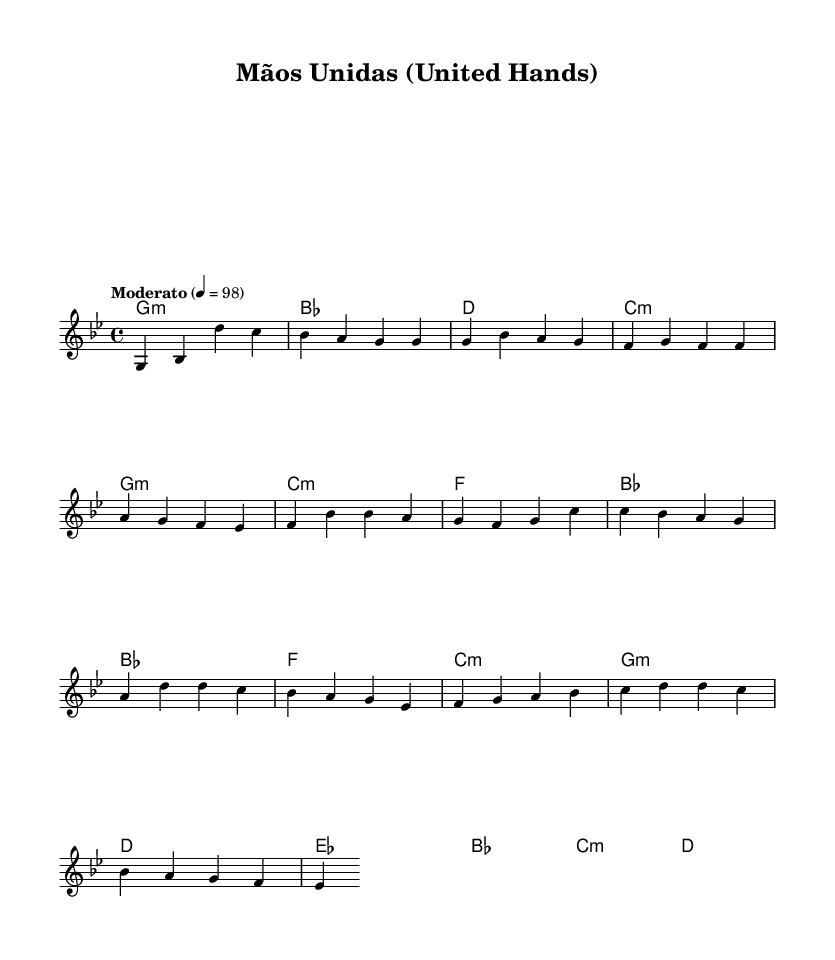What is the key signature of this music? The key signature is G minor, which has two flats. You can determine the key signature by looking at the beginning of the staff, which indicates the sharps or flats present. In this case, the G minor key signature is evident.
Answer: G minor What is the time signature of this piece? The time signature is 4/4, located at the beginning of the sheet music right after the clef and key signature. It shows that there are four beats in each measure and a quarter note receives one beat.
Answer: 4/4 What is the tempo marking for this piece? The tempo marking is "Moderato," which indicates a moderate pace for the song's performance. It is written above the staves, giving performers guidance on how quickly to play.
Answer: Moderato How many measures are there in the melody section? The melody section consists of five measures. You can count the measures by identifying the vertical lines that separate the notes, indicating the start and end of each measure.
Answer: 5 What type of harmony appears in the chorus section? The harmony in the chorus section is primarily represented using major chords, as indicated by the chords labeled above the melody notes in the chorus line. This can be seen clearly in the chord symbols written above the melody.
Answer: Major How does the melody of the bridge section compare to the verse? The melody in the bridge section specifically contains higher pitches and a different note pattern, creating a contrast to the verse melody that has a more repetitive structure. This difference brings variety to the piece.
Answer: Higher pitches 